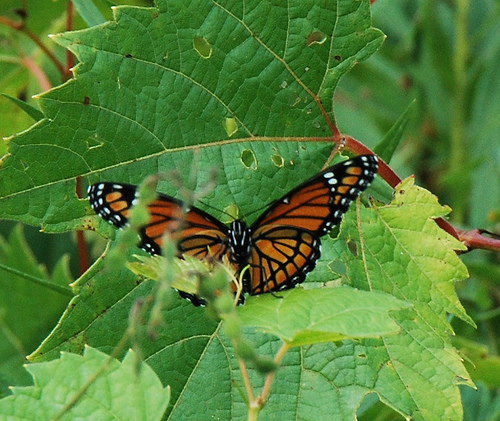<image>
Is there a black lines on the butterfly? Yes. Looking at the image, I can see the black lines is positioned on top of the butterfly, with the butterfly providing support. Is there a leaves behind the butterfly? Yes. From this viewpoint, the leaves is positioned behind the butterfly, with the butterfly partially or fully occluding the leaves. 